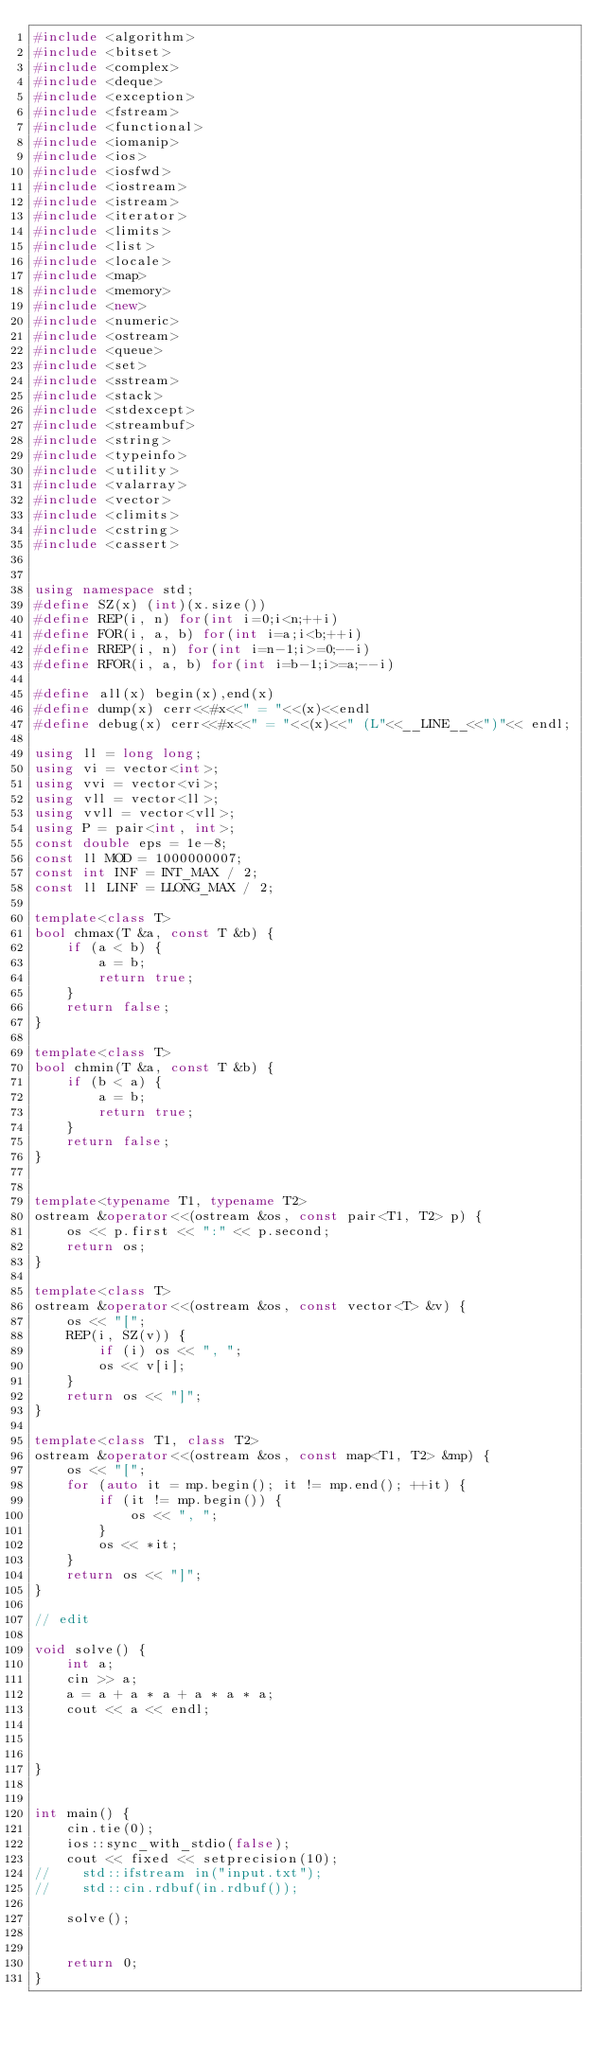<code> <loc_0><loc_0><loc_500><loc_500><_C++_>#include <algorithm>
#include <bitset>
#include <complex>
#include <deque>
#include <exception>
#include <fstream>
#include <functional>
#include <iomanip>
#include <ios>
#include <iosfwd>
#include <iostream>
#include <istream>
#include <iterator>
#include <limits>
#include <list>
#include <locale>
#include <map>
#include <memory>
#include <new>
#include <numeric>
#include <ostream>
#include <queue>
#include <set>
#include <sstream>
#include <stack>
#include <stdexcept>
#include <streambuf>
#include <string>
#include <typeinfo>
#include <utility>
#include <valarray>
#include <vector>
#include <climits>
#include <cstring>
#include <cassert>


using namespace std;
#define SZ(x) (int)(x.size())
#define REP(i, n) for(int i=0;i<n;++i)
#define FOR(i, a, b) for(int i=a;i<b;++i)
#define RREP(i, n) for(int i=n-1;i>=0;--i)
#define RFOR(i, a, b) for(int i=b-1;i>=a;--i)

#define all(x) begin(x),end(x)
#define dump(x) cerr<<#x<<" = "<<(x)<<endl
#define debug(x) cerr<<#x<<" = "<<(x)<<" (L"<<__LINE__<<")"<< endl;

using ll = long long;
using vi = vector<int>;
using vvi = vector<vi>;
using vll = vector<ll>;
using vvll = vector<vll>;
using P = pair<int, int>;
const double eps = 1e-8;
const ll MOD = 1000000007;
const int INF = INT_MAX / 2;
const ll LINF = LLONG_MAX / 2;

template<class T>
bool chmax(T &a, const T &b) {
    if (a < b) {
        a = b;
        return true;
    }
    return false;
}

template<class T>
bool chmin(T &a, const T &b) {
    if (b < a) {
        a = b;
        return true;
    }
    return false;
}


template<typename T1, typename T2>
ostream &operator<<(ostream &os, const pair<T1, T2> p) {
    os << p.first << ":" << p.second;
    return os;
}

template<class T>
ostream &operator<<(ostream &os, const vector<T> &v) {
    os << "[";
    REP(i, SZ(v)) {
        if (i) os << ", ";
        os << v[i];
    }
    return os << "]";
}

template<class T1, class T2>
ostream &operator<<(ostream &os, const map<T1, T2> &mp) {
    os << "[";
    for (auto it = mp.begin(); it != mp.end(); ++it) {
        if (it != mp.begin()) {
            os << ", ";
        }
        os << *it;
    }
    return os << "]";
}

// edit

void solve() {
    int a;
    cin >> a;
    a = a + a * a + a * a * a;
    cout << a << endl;



}


int main() {
    cin.tie(0);
    ios::sync_with_stdio(false);
    cout << fixed << setprecision(10);
//    std::ifstream in("input.txt");
//    std::cin.rdbuf(in.rdbuf());

    solve();


    return 0;
}
</code> 